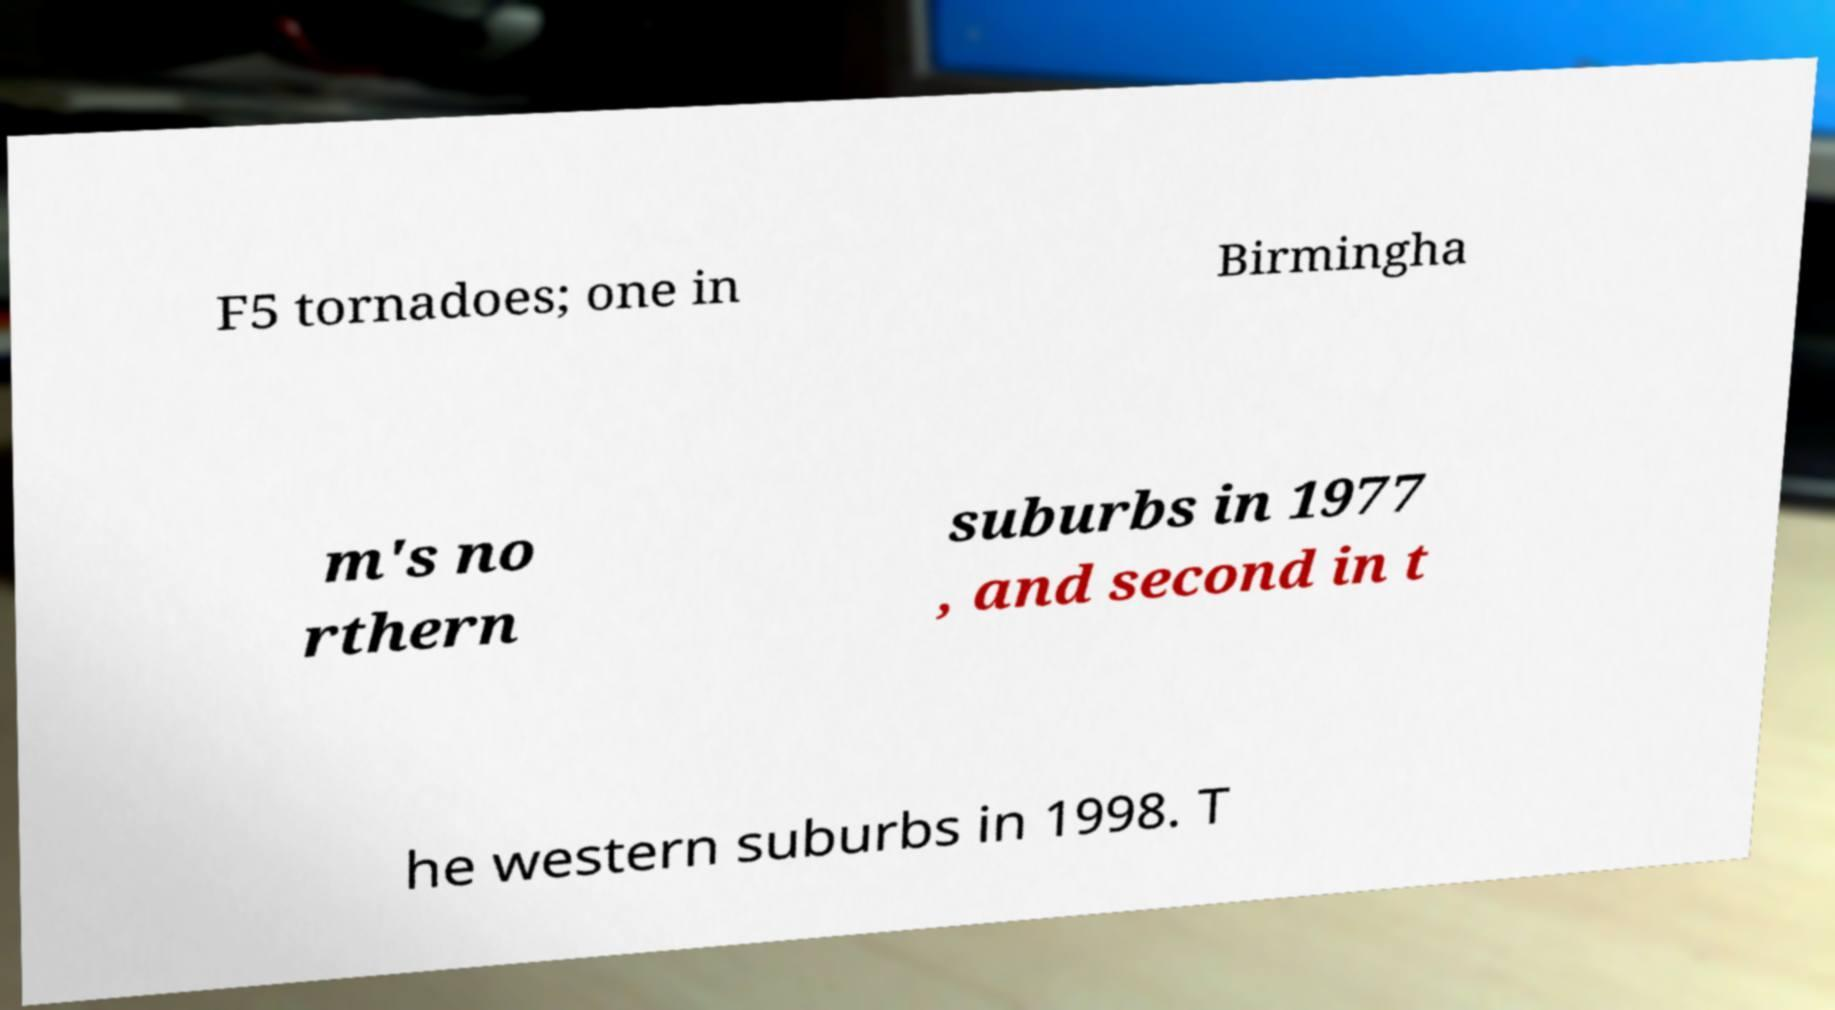Please identify and transcribe the text found in this image. F5 tornadoes; one in Birmingha m's no rthern suburbs in 1977 , and second in t he western suburbs in 1998. T 